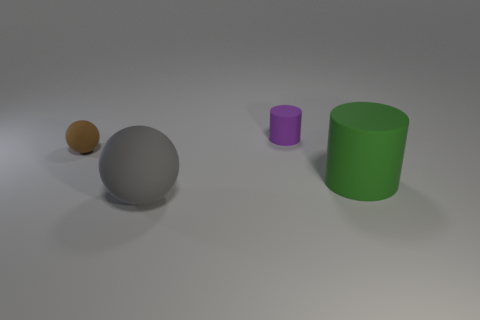Add 4 brown rubber spheres. How many objects exist? 8 Subtract all red rubber cubes. Subtract all tiny brown objects. How many objects are left? 3 Add 1 large green matte cylinders. How many large green matte cylinders are left? 2 Add 4 large gray rubber objects. How many large gray rubber objects exist? 5 Subtract 0 yellow balls. How many objects are left? 4 